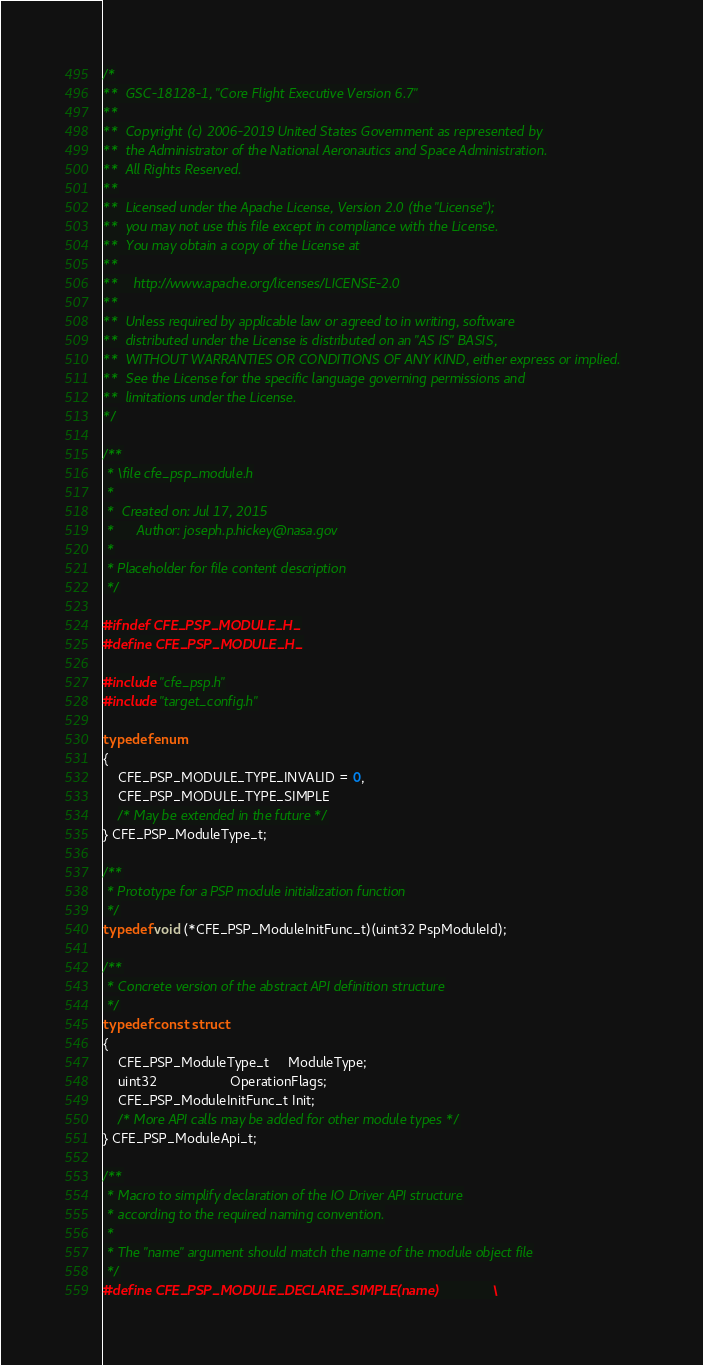<code> <loc_0><loc_0><loc_500><loc_500><_C_>/*
**  GSC-18128-1, "Core Flight Executive Version 6.7"
**
**  Copyright (c) 2006-2019 United States Government as represented by
**  the Administrator of the National Aeronautics and Space Administration.
**  All Rights Reserved.
**
**  Licensed under the Apache License, Version 2.0 (the "License");
**  you may not use this file except in compliance with the License.
**  You may obtain a copy of the License at
**
**    http://www.apache.org/licenses/LICENSE-2.0
**
**  Unless required by applicable law or agreed to in writing, software
**  distributed under the License is distributed on an "AS IS" BASIS,
**  WITHOUT WARRANTIES OR CONDITIONS OF ANY KIND, either express or implied.
**  See the License for the specific language governing permissions and
**  limitations under the License.
*/

/**
 * \file cfe_psp_module.h
 *
 *  Created on: Jul 17, 2015
 *      Author: joseph.p.hickey@nasa.gov
 *
 * Placeholder for file content description
 */

#ifndef CFE_PSP_MODULE_H_
#define CFE_PSP_MODULE_H_

#include "cfe_psp.h"
#include "target_config.h"

typedef enum
{
    CFE_PSP_MODULE_TYPE_INVALID = 0,
    CFE_PSP_MODULE_TYPE_SIMPLE
    /* May be extended in the future */
} CFE_PSP_ModuleType_t;

/**
 * Prototype for a PSP module initialization function
 */
typedef void (*CFE_PSP_ModuleInitFunc_t)(uint32 PspModuleId);

/**
 * Concrete version of the abstract API definition structure
 */
typedef const struct
{
    CFE_PSP_ModuleType_t     ModuleType;
    uint32                   OperationFlags;
    CFE_PSP_ModuleInitFunc_t Init;
    /* More API calls may be added for other module types */
} CFE_PSP_ModuleApi_t;

/**
 * Macro to simplify declaration of the IO Driver API structure
 * according to the required naming convention.
 *
 * The "name" argument should match the name of the module object file
 */
#define CFE_PSP_MODULE_DECLARE_SIMPLE(name)              \</code> 